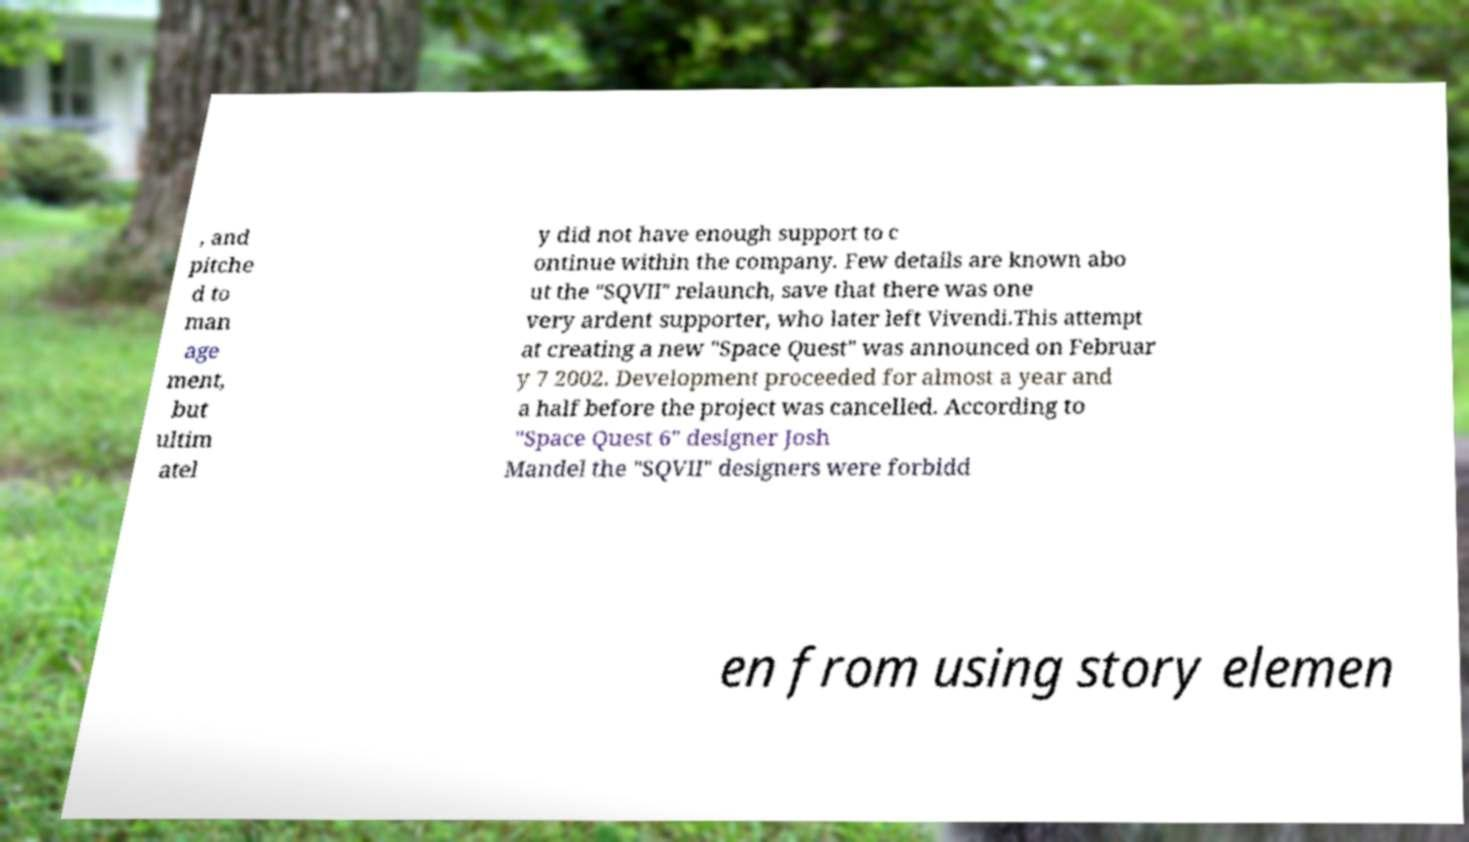Could you assist in decoding the text presented in this image and type it out clearly? , and pitche d to man age ment, but ultim atel y did not have enough support to c ontinue within the company. Few details are known abo ut the "SQVII" relaunch, save that there was one very ardent supporter, who later left Vivendi.This attempt at creating a new "Space Quest" was announced on Februar y 7 2002. Development proceeded for almost a year and a half before the project was cancelled. According to "Space Quest 6" designer Josh Mandel the "SQVII" designers were forbidd en from using story elemen 